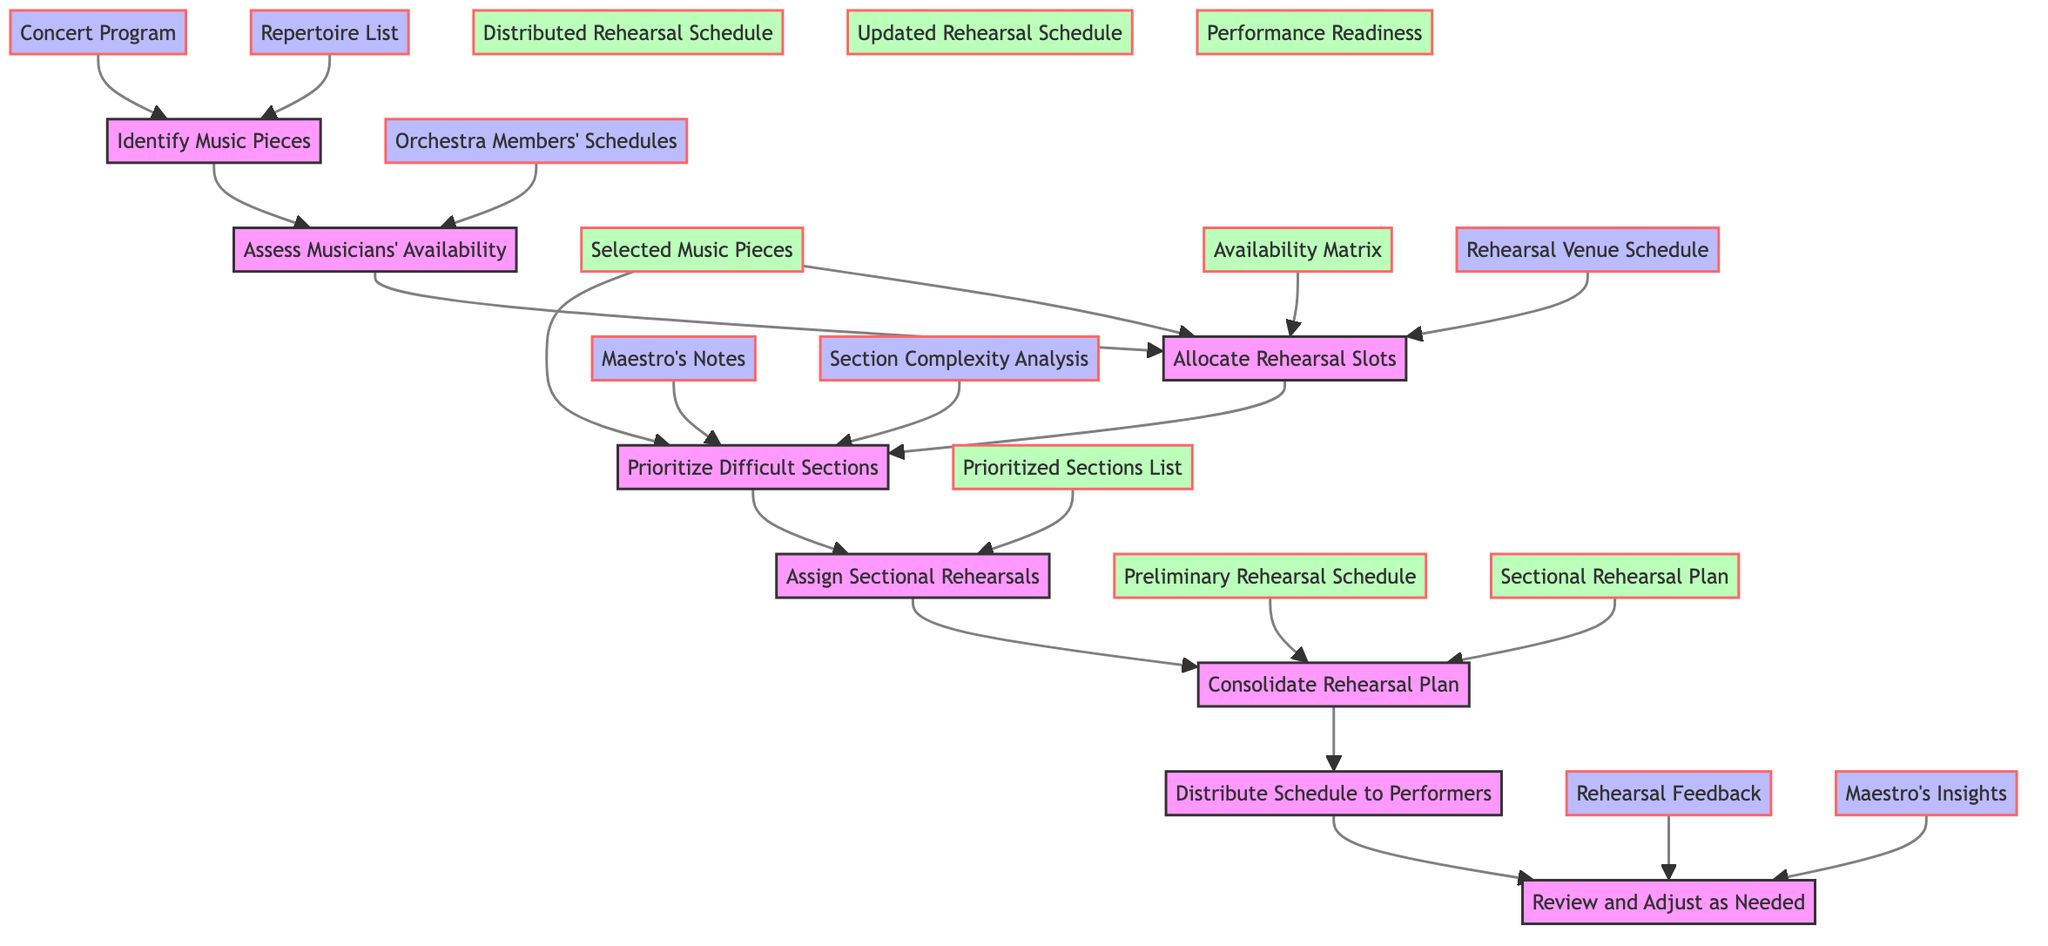What is the first step in the flowchart? The first step in the flowchart is to "Identify Music Pieces." This can be found at the top of the flowchart, indicating it is the starting point of the process.
Answer: Identify Music Pieces How many output nodes are in the diagram? By reviewing the flowchart, we can see six distinct output nodes: Selected Music Pieces, Availability Matrix, Preliminary Rehearsal Schedule, Prioritized Sections List, Sectional Rehearsal Plan, and Distributed Rehearsal Schedule.
Answer: Six Which step follows "Assess Musicians' Availability"? After "Assess Musicians' Availability," the next step is "Allocate Rehearsal Slots." This is indicated by the directed arrow connecting these two nodes.
Answer: Allocate Rehearsal Slots What inputs are needed for "Prioritize Difficult Sections"? To "Prioritize Difficult Sections," three inputs are needed: Selected Music Pieces, Maestro's Notes, and Section Complexity Analysis, as shown in the flowchart connected to that step.
Answer: Selected Music Pieces, Maestro's Notes, Section Complexity Analysis What is the last step in the flowchart? The last step in the flowchart is "Review and Adjust as Needed." It is positioned at the bottom of the diagram, indicating it is the concluding action in the rehearsal scheduling process.
Answer: Review and Adjust as Needed How does the 'Distribute Schedule to Performers' relate to 'Consolidate Rehearsal Plan'? "Distribute Schedule to Performers" is the step that follows "Consolidate Rehearsal Plan," meaning once the rehearsal plans are integrated, the schedule is shared with performers, indicating a sequential relationship.
Answer: It follows it in the process Which input contributes to both the "Allocate Rehearsal Slots" and "Consolidate Rehearsal Plan"? The input that contributes to both "Allocate Rehearsal Slots" and "Consolidate Rehearsal Plan" is the "Availability Matrix," as shown in the arrows originating from this node leading to both subsequent steps.
Answer: Availability Matrix What outputs are produced after the "Review and Adjust as Needed" step? The outputs produced after "Review and Adjust as Needed" include "Updated Rehearsal Schedule" and "Performance Readiness," demonstrating the end results of this stage in the process as indicated by the outputs connected to it.
Answer: Updated Rehearsal Schedule, Performance Readiness 